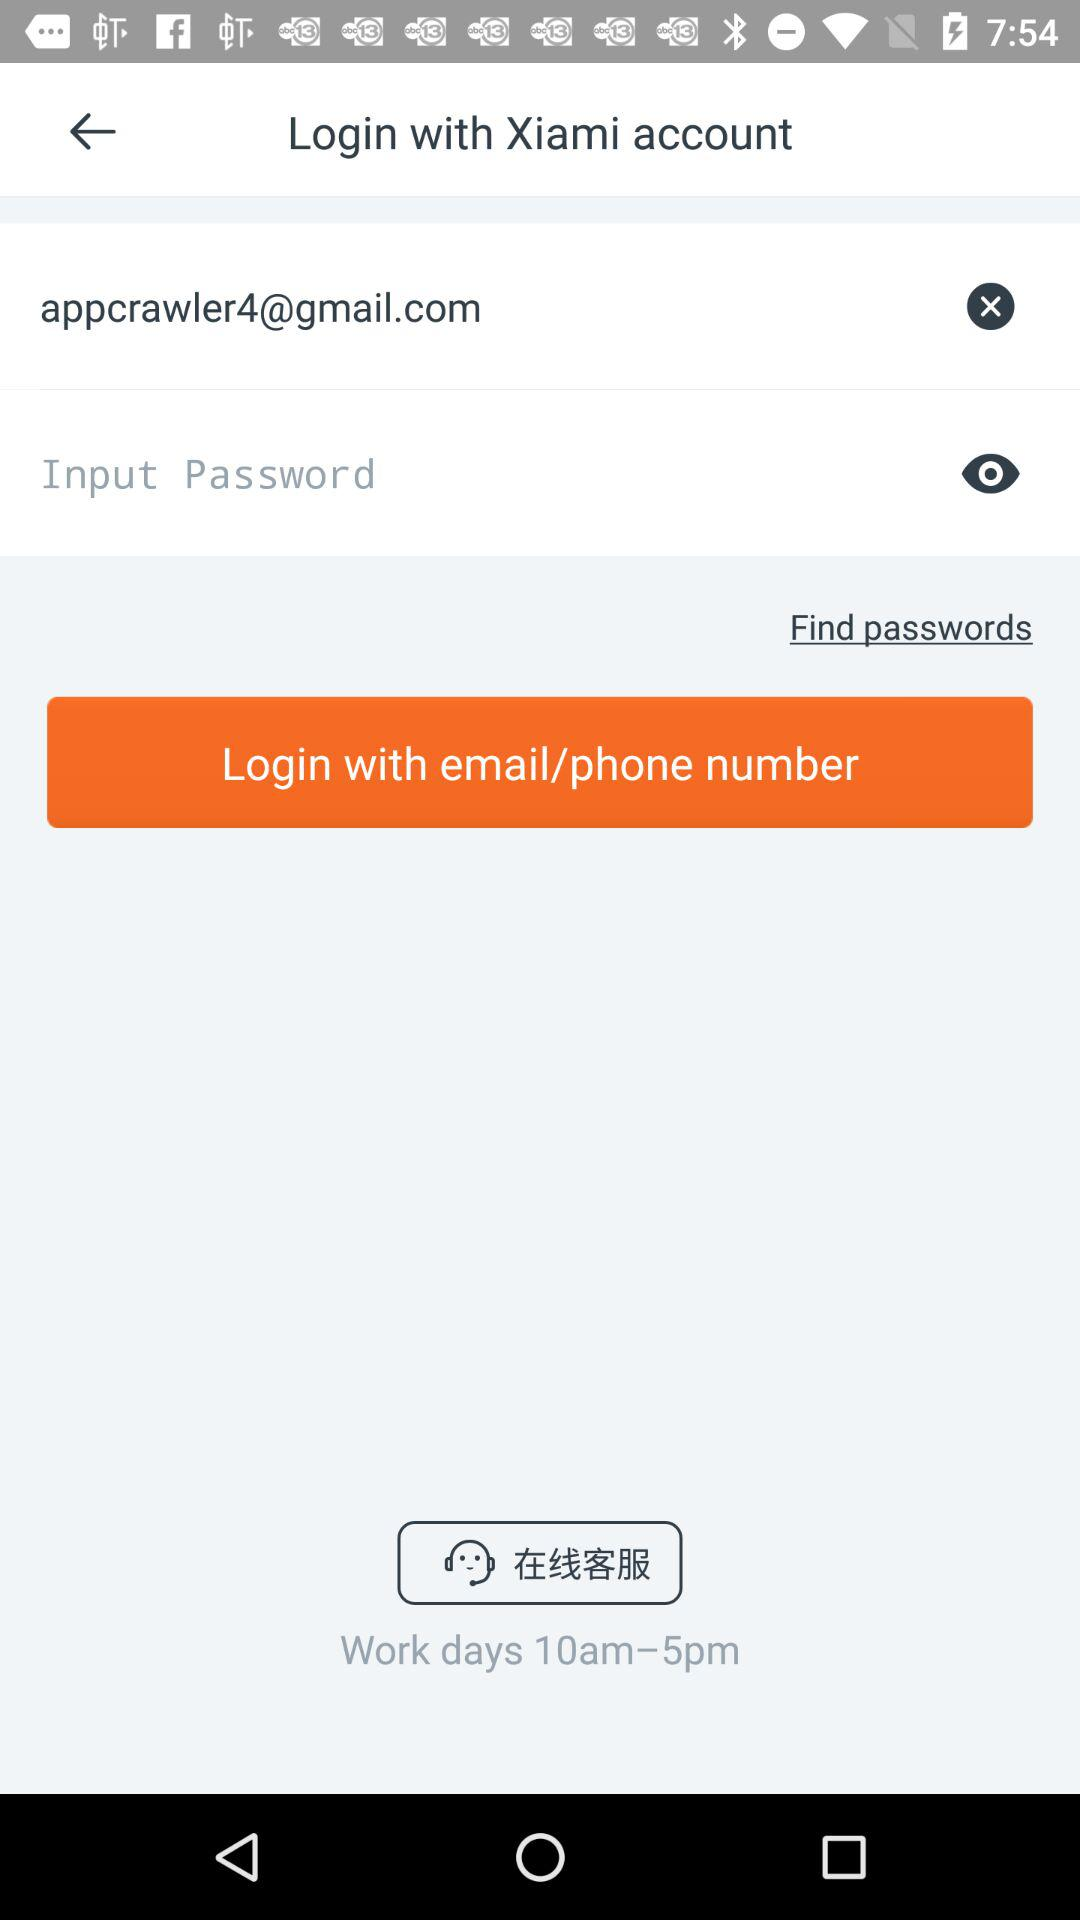What is the email address? The email address is "appcrawler4@gmail.com". 